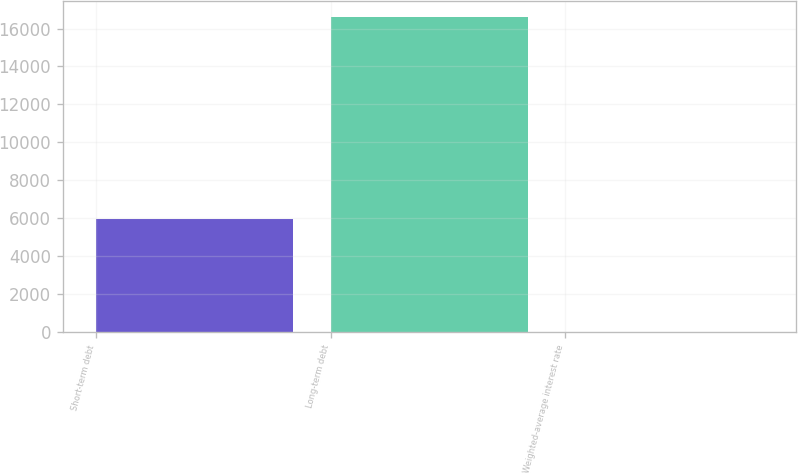Convert chart. <chart><loc_0><loc_0><loc_500><loc_500><bar_chart><fcel>Short-term debt<fcel>Long-term debt<fcel>Weighted-average interest rate<nl><fcel>5979<fcel>16608<fcel>3<nl></chart> 